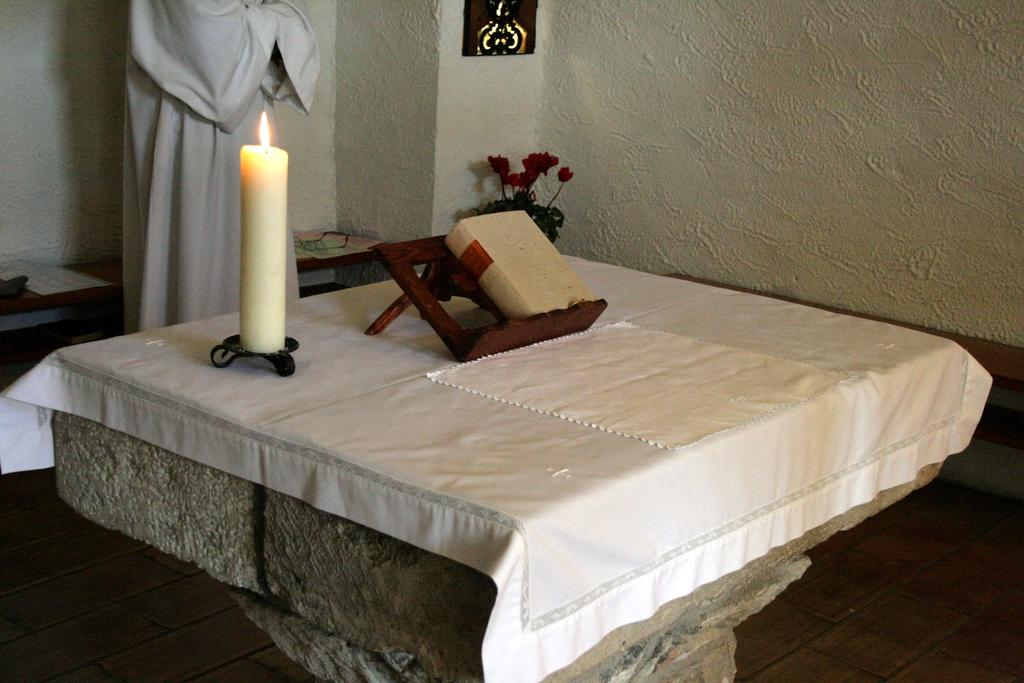What is one of the main objects in the image? There is a candle in the image. What else can be seen in the image? There is a book, a stand, and an idol in the image. Where are these objects located? They are on a table in the image. What can be seen in the background of the image? There is a wall and flowers in the background of the image. Are there any other objects visible in the background? Yes, there are objects on the table in the background of the image. What type of oatmeal is being served in the image? There is no oatmeal present in the image. What kind of office furniture can be seen in the image? There is no office furniture present in the image. 